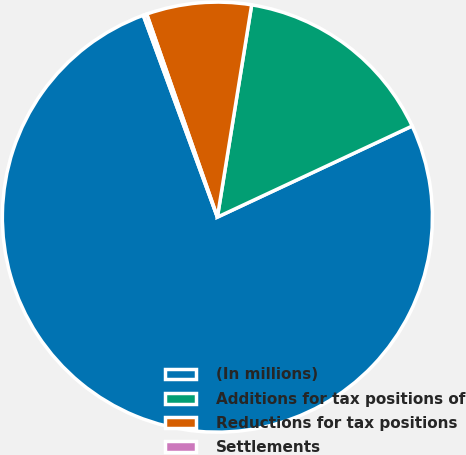<chart> <loc_0><loc_0><loc_500><loc_500><pie_chart><fcel>(In millions)<fcel>Additions for tax positions of<fcel>Reductions for tax positions<fcel>Settlements<nl><fcel>76.37%<fcel>15.49%<fcel>7.88%<fcel>0.27%<nl></chart> 